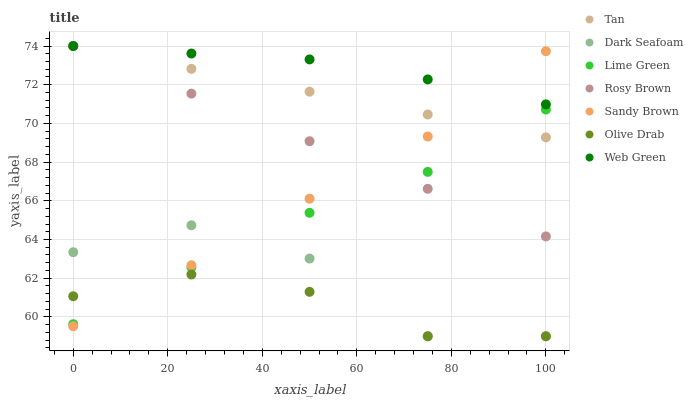Does Olive Drab have the minimum area under the curve?
Answer yes or no. Yes. Does Web Green have the maximum area under the curve?
Answer yes or no. Yes. Does Rosy Brown have the minimum area under the curve?
Answer yes or no. No. Does Rosy Brown have the maximum area under the curve?
Answer yes or no. No. Is Tan the smoothest?
Answer yes or no. Yes. Is Dark Seafoam the roughest?
Answer yes or no. Yes. Is Rosy Brown the smoothest?
Answer yes or no. No. Is Rosy Brown the roughest?
Answer yes or no. No. Does Dark Seafoam have the lowest value?
Answer yes or no. Yes. Does Rosy Brown have the lowest value?
Answer yes or no. No. Does Tan have the highest value?
Answer yes or no. Yes. Does Dark Seafoam have the highest value?
Answer yes or no. No. Is Lime Green less than Web Green?
Answer yes or no. Yes. Is Rosy Brown greater than Dark Seafoam?
Answer yes or no. Yes. Does Dark Seafoam intersect Olive Drab?
Answer yes or no. Yes. Is Dark Seafoam less than Olive Drab?
Answer yes or no. No. Is Dark Seafoam greater than Olive Drab?
Answer yes or no. No. Does Lime Green intersect Web Green?
Answer yes or no. No. 